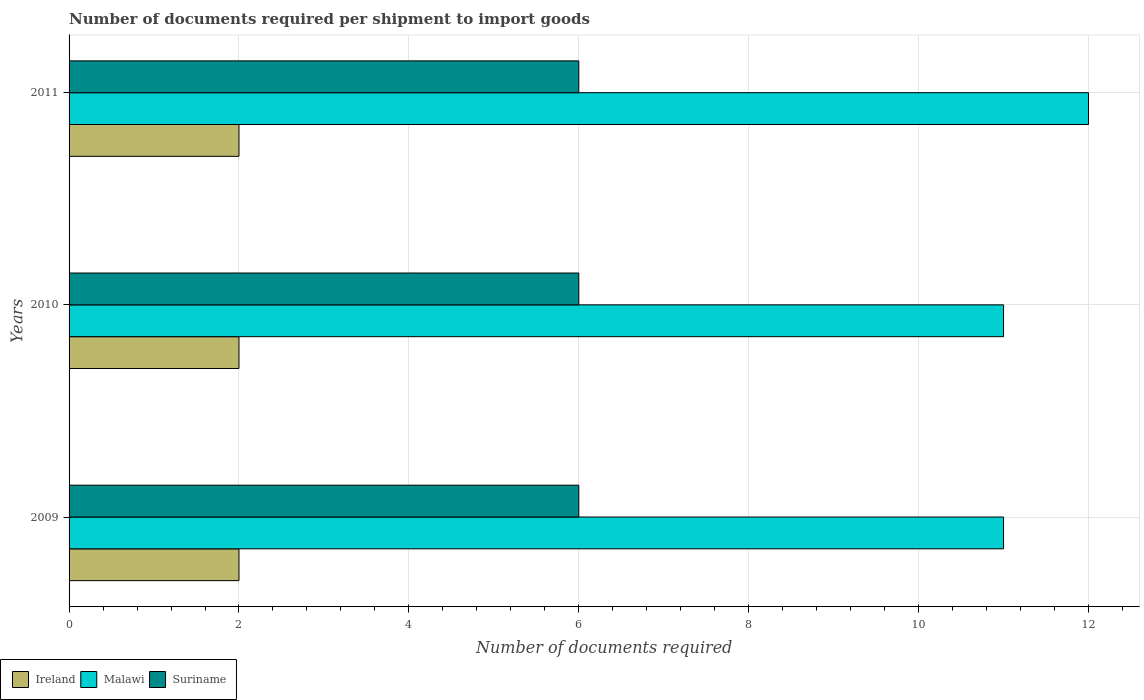How many different coloured bars are there?
Keep it short and to the point. 3. How many groups of bars are there?
Offer a terse response. 3. Are the number of bars per tick equal to the number of legend labels?
Offer a terse response. Yes. Are the number of bars on each tick of the Y-axis equal?
Provide a short and direct response. Yes. How many bars are there on the 3rd tick from the bottom?
Your answer should be compact. 3. What is the label of the 1st group of bars from the top?
Provide a short and direct response. 2011. In how many cases, is the number of bars for a given year not equal to the number of legend labels?
Provide a short and direct response. 0. What is the number of documents required per shipment to import goods in Malawi in 2011?
Offer a very short reply. 12. Across all years, what is the minimum number of documents required per shipment to import goods in Malawi?
Keep it short and to the point. 11. What is the difference between the number of documents required per shipment to import goods in Suriname in 2010 and that in 2011?
Offer a very short reply. 0. What is the difference between the number of documents required per shipment to import goods in Malawi in 2009 and the number of documents required per shipment to import goods in Suriname in 2011?
Offer a terse response. 5. What is the average number of documents required per shipment to import goods in Suriname per year?
Give a very brief answer. 6. In the year 2010, what is the difference between the number of documents required per shipment to import goods in Malawi and number of documents required per shipment to import goods in Suriname?
Your response must be concise. 5. In how many years, is the number of documents required per shipment to import goods in Malawi greater than 11.2 ?
Your answer should be compact. 1. Is the number of documents required per shipment to import goods in Malawi in 2009 less than that in 2011?
Provide a short and direct response. Yes. What is the difference between the highest and the second highest number of documents required per shipment to import goods in Suriname?
Keep it short and to the point. 0. What is the difference between the highest and the lowest number of documents required per shipment to import goods in Malawi?
Ensure brevity in your answer.  1. In how many years, is the number of documents required per shipment to import goods in Malawi greater than the average number of documents required per shipment to import goods in Malawi taken over all years?
Offer a terse response. 1. What does the 1st bar from the top in 2010 represents?
Your response must be concise. Suriname. What does the 3rd bar from the bottom in 2009 represents?
Provide a succinct answer. Suriname. Are all the bars in the graph horizontal?
Your answer should be very brief. Yes. Are the values on the major ticks of X-axis written in scientific E-notation?
Provide a short and direct response. No. Does the graph contain any zero values?
Keep it short and to the point. No. Where does the legend appear in the graph?
Your response must be concise. Bottom left. How many legend labels are there?
Offer a very short reply. 3. What is the title of the graph?
Provide a short and direct response. Number of documents required per shipment to import goods. What is the label or title of the X-axis?
Provide a short and direct response. Number of documents required. What is the label or title of the Y-axis?
Ensure brevity in your answer.  Years. What is the Number of documents required of Suriname in 2009?
Provide a succinct answer. 6. What is the Number of documents required of Ireland in 2010?
Your response must be concise. 2. What is the Number of documents required in Suriname in 2010?
Your answer should be compact. 6. What is the Number of documents required in Malawi in 2011?
Keep it short and to the point. 12. Across all years, what is the maximum Number of documents required in Ireland?
Provide a short and direct response. 2. Across all years, what is the maximum Number of documents required of Malawi?
Keep it short and to the point. 12. Across all years, what is the maximum Number of documents required of Suriname?
Ensure brevity in your answer.  6. What is the total Number of documents required of Ireland in the graph?
Make the answer very short. 6. What is the total Number of documents required in Malawi in the graph?
Your answer should be compact. 34. What is the total Number of documents required in Suriname in the graph?
Keep it short and to the point. 18. What is the difference between the Number of documents required in Malawi in 2009 and that in 2010?
Ensure brevity in your answer.  0. What is the difference between the Number of documents required of Suriname in 2009 and that in 2010?
Ensure brevity in your answer.  0. What is the difference between the Number of documents required of Ireland in 2009 and that in 2011?
Offer a terse response. 0. What is the difference between the Number of documents required in Malawi in 2009 and that in 2011?
Keep it short and to the point. -1. What is the difference between the Number of documents required of Suriname in 2009 and that in 2011?
Ensure brevity in your answer.  0. What is the difference between the Number of documents required of Ireland in 2010 and that in 2011?
Make the answer very short. 0. What is the difference between the Number of documents required of Suriname in 2010 and that in 2011?
Provide a short and direct response. 0. What is the difference between the Number of documents required in Ireland in 2009 and the Number of documents required in Malawi in 2010?
Ensure brevity in your answer.  -9. What is the difference between the Number of documents required in Ireland in 2009 and the Number of documents required in Suriname in 2010?
Make the answer very short. -4. What is the difference between the Number of documents required of Ireland in 2009 and the Number of documents required of Malawi in 2011?
Your answer should be compact. -10. What is the average Number of documents required in Malawi per year?
Ensure brevity in your answer.  11.33. What is the average Number of documents required of Suriname per year?
Your answer should be very brief. 6. In the year 2009, what is the difference between the Number of documents required in Ireland and Number of documents required in Malawi?
Give a very brief answer. -9. In the year 2009, what is the difference between the Number of documents required of Malawi and Number of documents required of Suriname?
Ensure brevity in your answer.  5. In the year 2010, what is the difference between the Number of documents required of Ireland and Number of documents required of Malawi?
Give a very brief answer. -9. In the year 2011, what is the difference between the Number of documents required of Ireland and Number of documents required of Suriname?
Provide a short and direct response. -4. What is the ratio of the Number of documents required of Ireland in 2009 to that in 2010?
Ensure brevity in your answer.  1. What is the ratio of the Number of documents required in Suriname in 2009 to that in 2010?
Your answer should be compact. 1. What is the ratio of the Number of documents required of Malawi in 2009 to that in 2011?
Ensure brevity in your answer.  0.92. What is the ratio of the Number of documents required of Suriname in 2009 to that in 2011?
Keep it short and to the point. 1. What is the ratio of the Number of documents required of Malawi in 2010 to that in 2011?
Give a very brief answer. 0.92. What is the difference between the highest and the lowest Number of documents required in Ireland?
Keep it short and to the point. 0. What is the difference between the highest and the lowest Number of documents required of Malawi?
Make the answer very short. 1. 